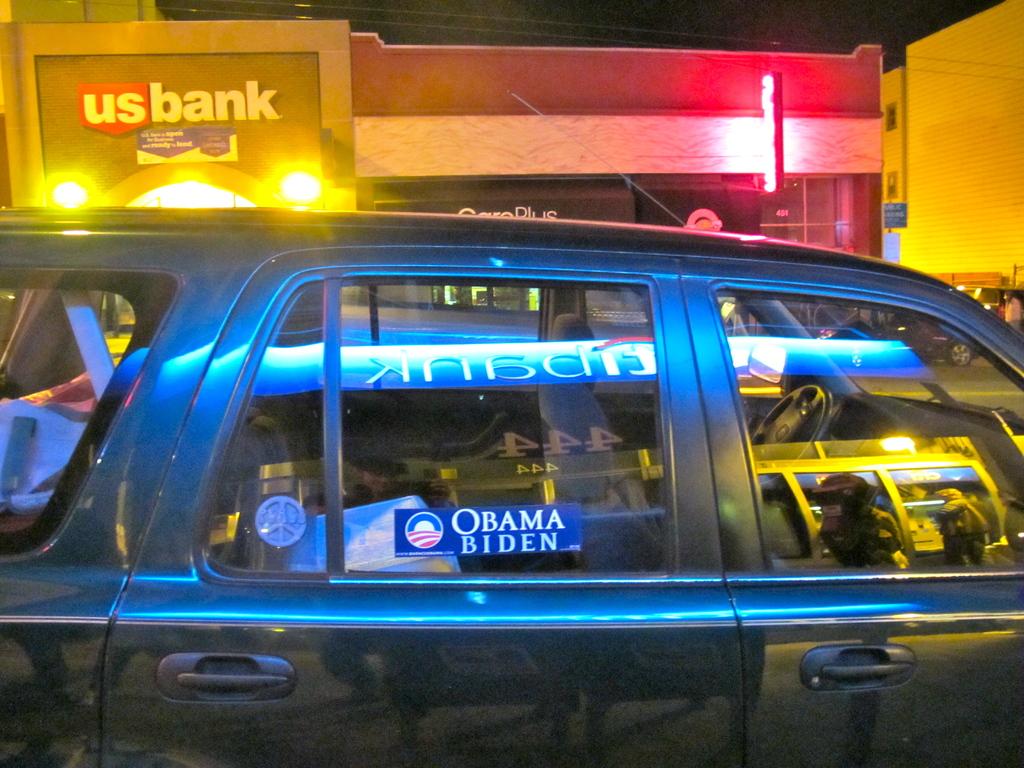Which president does the bumper sticker show support for?
Offer a very short reply. Obama. 